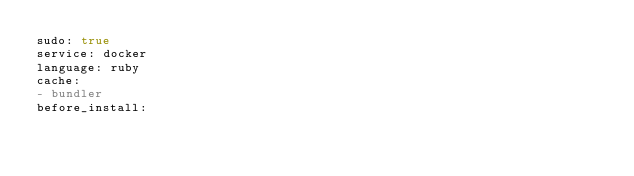<code> <loc_0><loc_0><loc_500><loc_500><_YAML_>sudo: true
service: docker
language: ruby
cache:
- bundler
before_install:</code> 